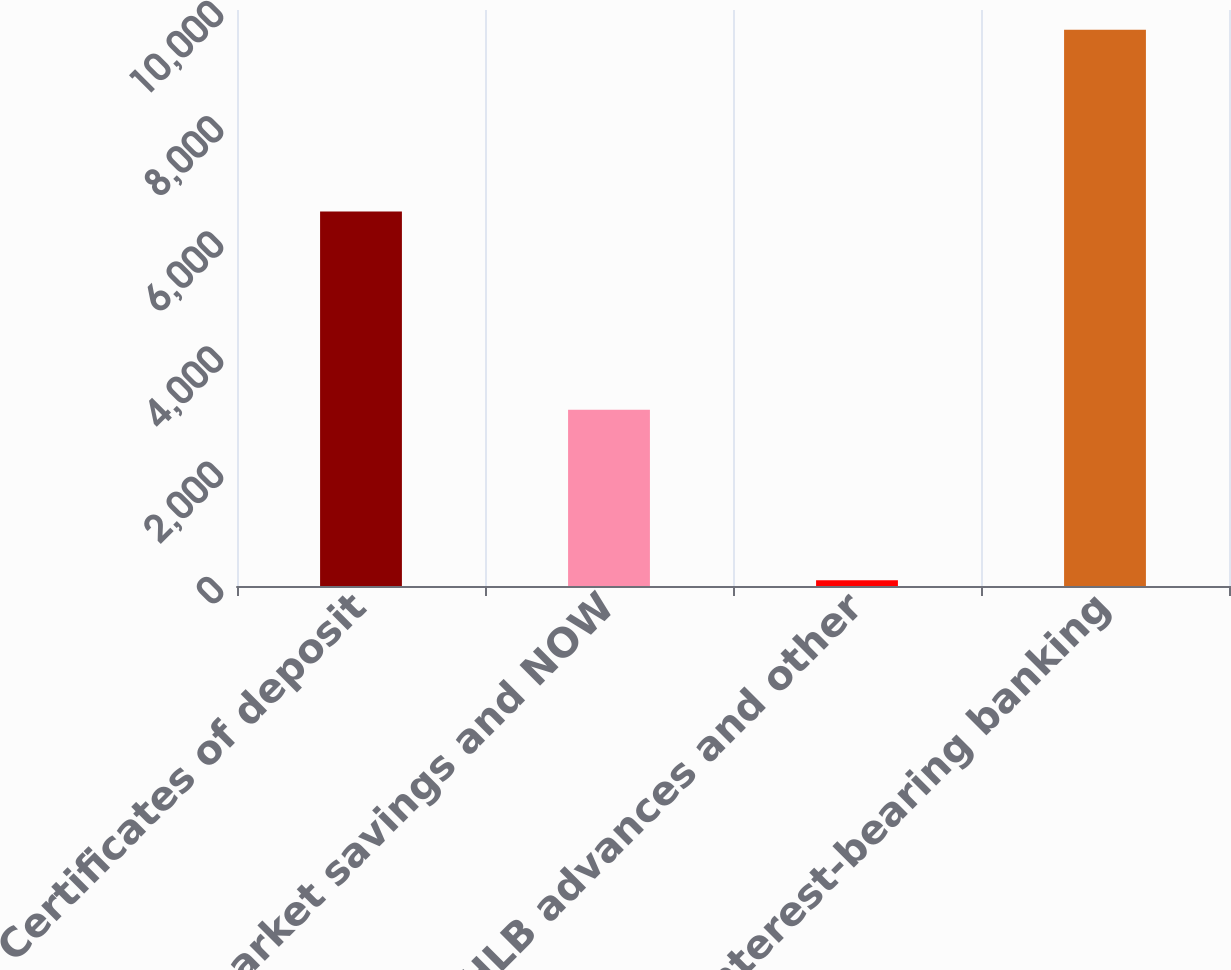<chart> <loc_0><loc_0><loc_500><loc_500><bar_chart><fcel>Certificates of deposit<fcel>Money market savings and NOW<fcel>FHLB advances and other<fcel>Total interest-bearing banking<nl><fcel>6501<fcel>3060<fcel>98<fcel>9659<nl></chart> 